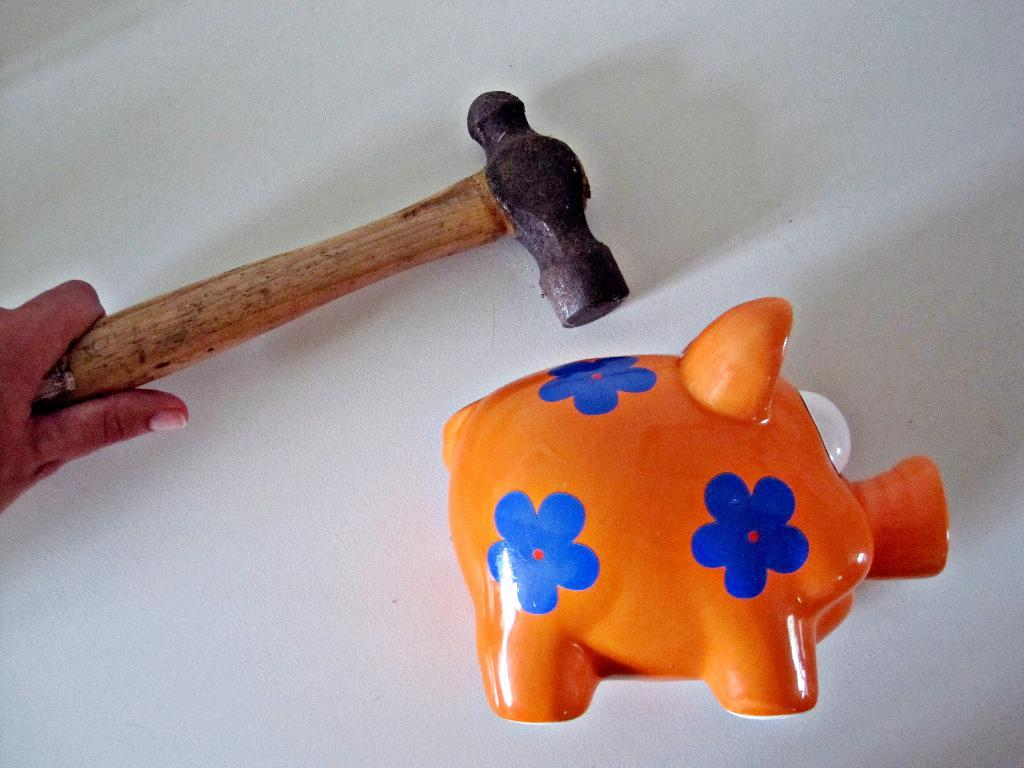What is being held by the hand in the image? The hand is holding a hammer. What else can be seen in the image besides the hand and hammer? There is a toy in the image. What is the color of the background in the image? The background of the image is white. How many chickens can be seen in the image? There are no chickens present in the image. What type of zephyr is being used to create the toy in the image? There is no zephyr present in the image, and the toy's creation method is not mentioned. 